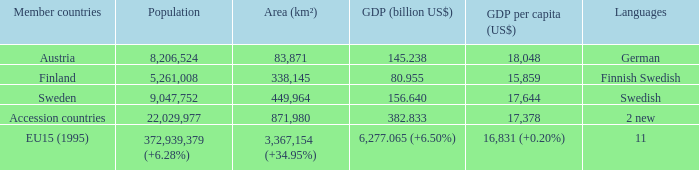Write the full table. {'header': ['Member countries', 'Population', 'Area (km²)', 'GDP (billion US$)', 'GDP per capita (US$)', 'Languages'], 'rows': [['Austria', '8,206,524', '83,871', '145.238', '18,048', 'German'], ['Finland', '5,261,008', '338,145', '80.955', '15,859', 'Finnish Swedish'], ['Sweden', '9,047,752', '449,964', '156.640', '17,644', 'Swedish'], ['Accession countries', '22,029,977', '871,980', '382.833', '17,378', '2 new'], ['EU15 (1995)', '372,939,379 (+6.28%)', '3,367,154 (+34.95%)', '6,277.065 (+6.50%)', '16,831 (+0.20%)', '11']]} Name the population for 11 languages 372,939,379 (+6.28%). 